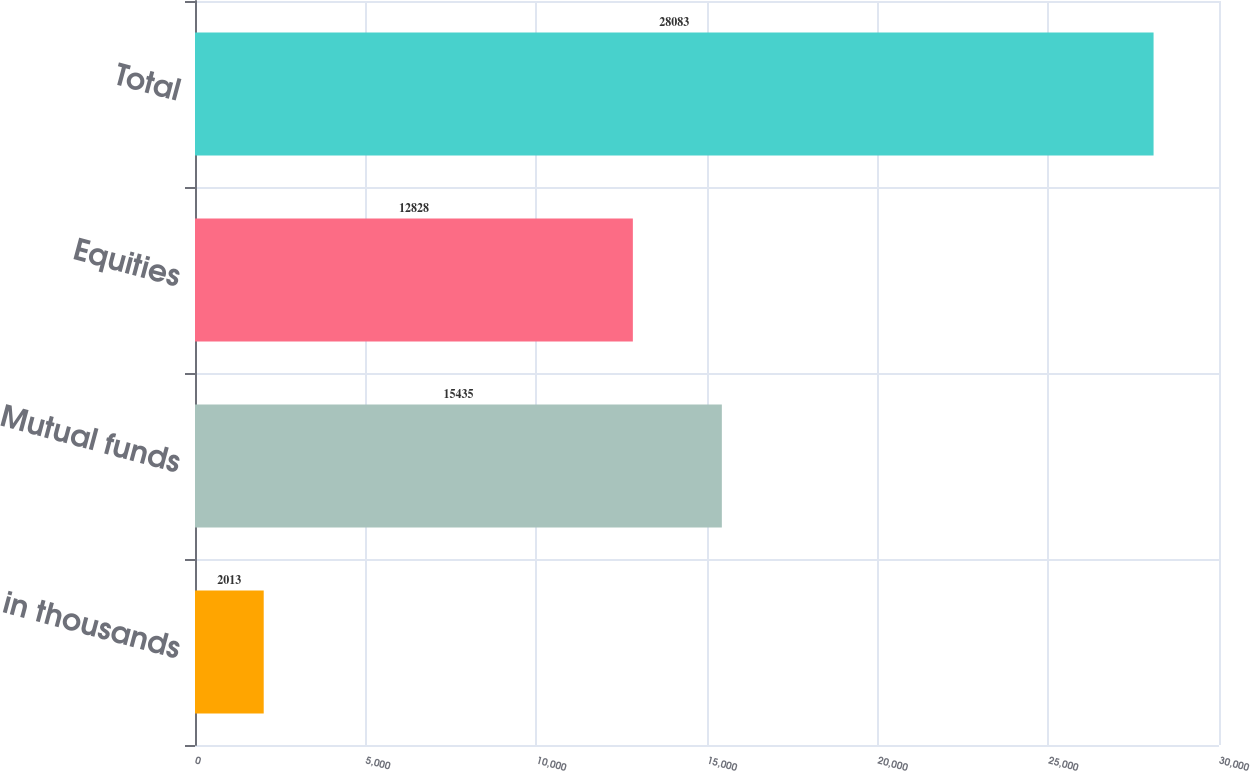<chart> <loc_0><loc_0><loc_500><loc_500><bar_chart><fcel>in thousands<fcel>Mutual funds<fcel>Equities<fcel>Total<nl><fcel>2013<fcel>15435<fcel>12828<fcel>28083<nl></chart> 